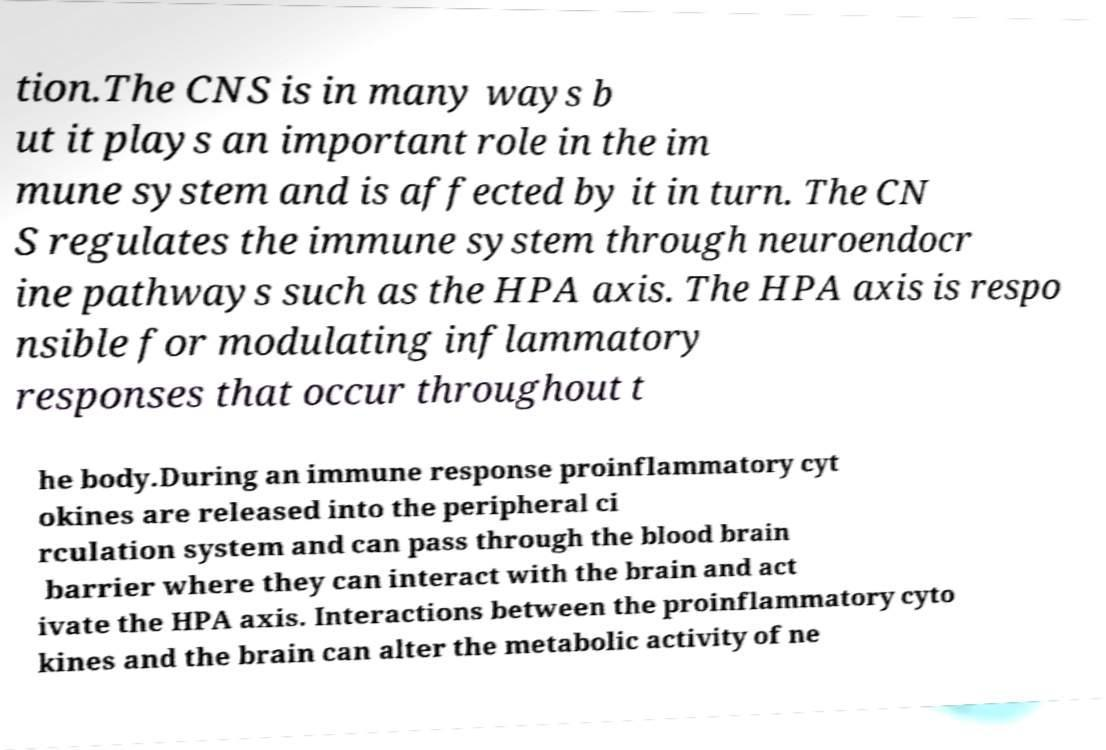For documentation purposes, I need the text within this image transcribed. Could you provide that? tion.The CNS is in many ways b ut it plays an important role in the im mune system and is affected by it in turn. The CN S regulates the immune system through neuroendocr ine pathways such as the HPA axis. The HPA axis is respo nsible for modulating inflammatory responses that occur throughout t he body.During an immune response proinflammatory cyt okines are released into the peripheral ci rculation system and can pass through the blood brain barrier where they can interact with the brain and act ivate the HPA axis. Interactions between the proinflammatory cyto kines and the brain can alter the metabolic activity of ne 